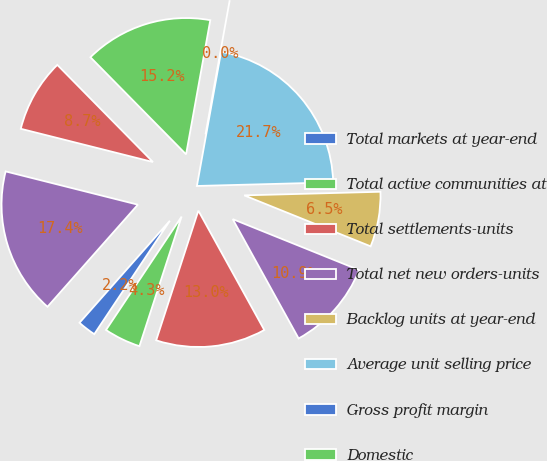Convert chart. <chart><loc_0><loc_0><loc_500><loc_500><pie_chart><fcel>Total markets at year-end<fcel>Total active communities at<fcel>Total settlements-units<fcel>Total net new orders-units<fcel>Backlog units at year-end<fcel>Average unit selling price<fcel>Gross profit margin<fcel>Domestic<fcel>International<fcel>Total Pulte and<nl><fcel>2.18%<fcel>4.35%<fcel>13.04%<fcel>10.87%<fcel>6.52%<fcel>21.74%<fcel>0.0%<fcel>15.22%<fcel>8.7%<fcel>17.39%<nl></chart> 